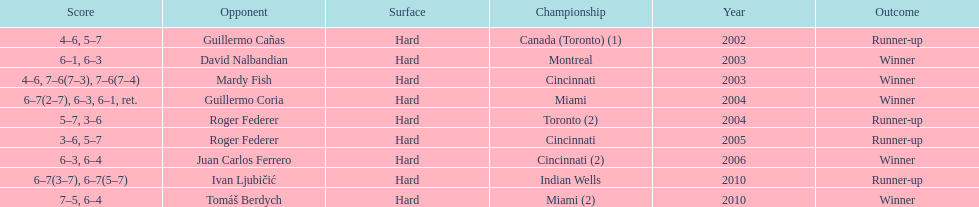How many occasions was the championship in miami? 2. 